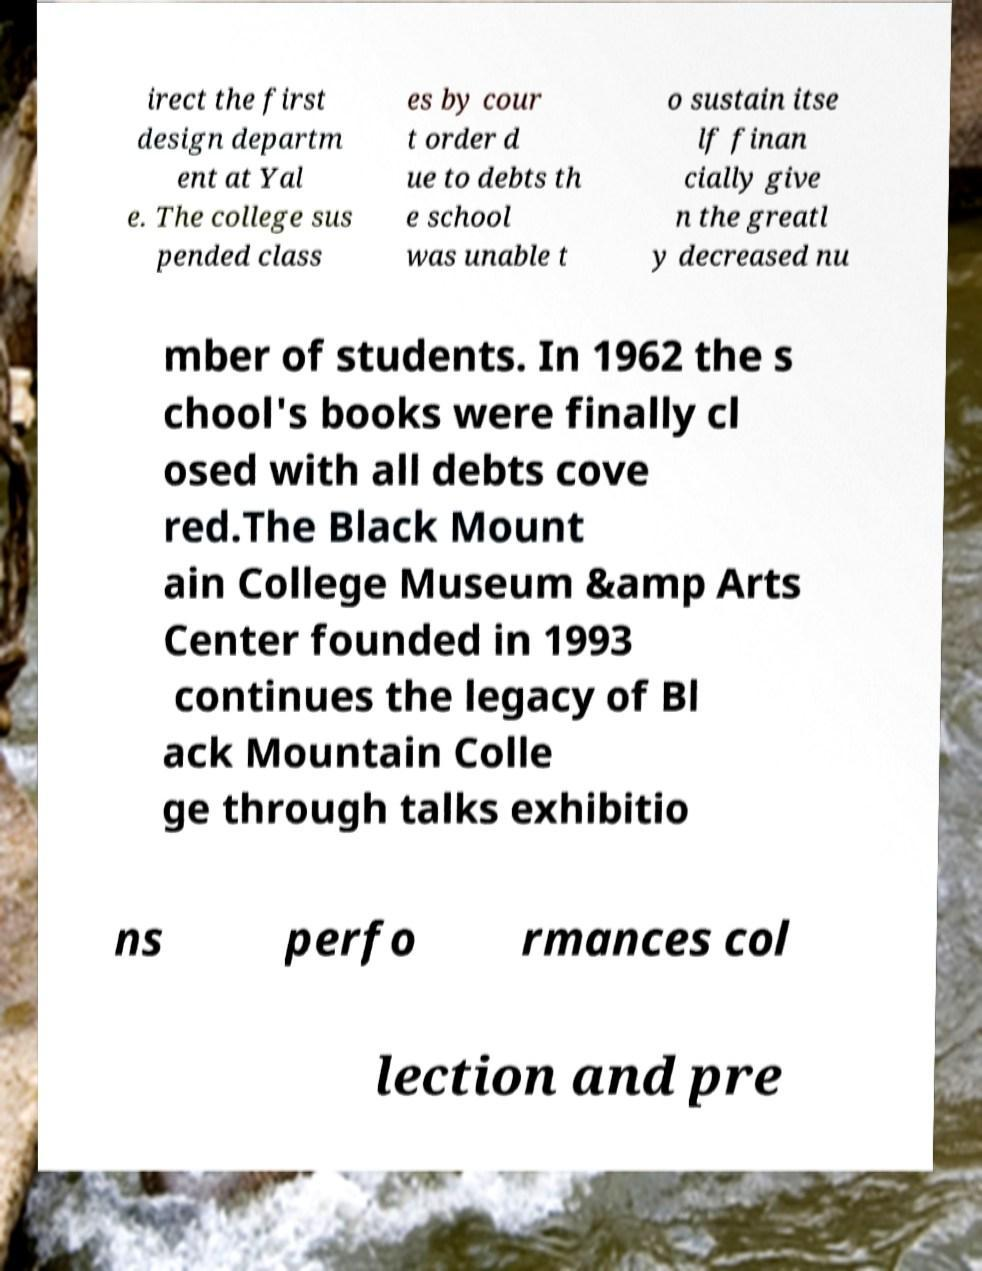There's text embedded in this image that I need extracted. Can you transcribe it verbatim? irect the first design departm ent at Yal e. The college sus pended class es by cour t order d ue to debts th e school was unable t o sustain itse lf finan cially give n the greatl y decreased nu mber of students. In 1962 the s chool's books were finally cl osed with all debts cove red.The Black Mount ain College Museum &amp Arts Center founded in 1993 continues the legacy of Bl ack Mountain Colle ge through talks exhibitio ns perfo rmances col lection and pre 